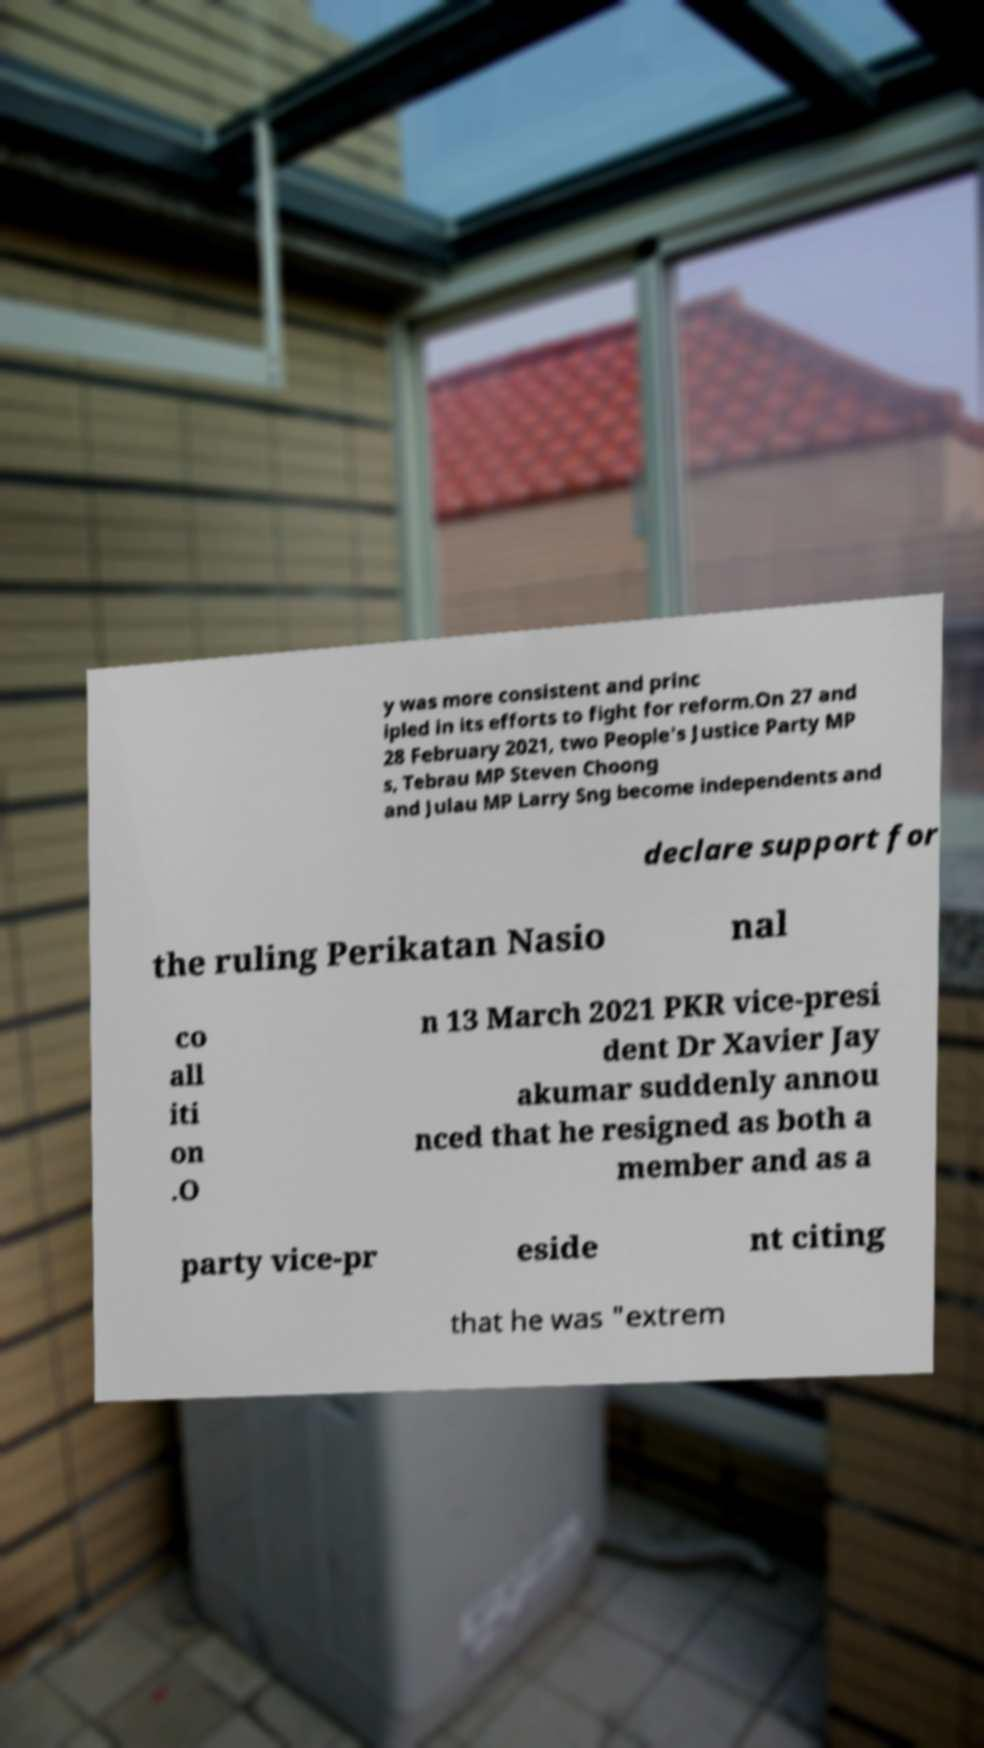Please read and relay the text visible in this image. What does it say? y was more consistent and princ ipled in its efforts to fight for reform.On 27 and 28 February 2021, two People's Justice Party MP s, Tebrau MP Steven Choong and Julau MP Larry Sng become independents and declare support for the ruling Perikatan Nasio nal co all iti on .O n 13 March 2021 PKR vice-presi dent Dr Xavier Jay akumar suddenly annou nced that he resigned as both a member and as a party vice-pr eside nt citing that he was "extrem 